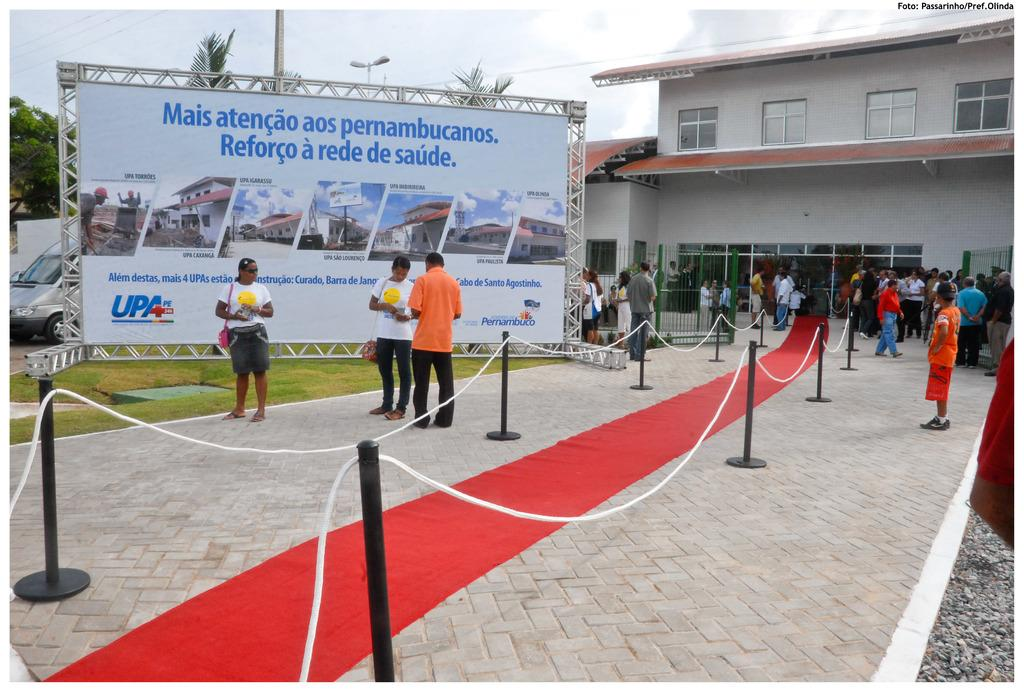What is the main structure visible in the image? There is a building in the image. Are there any people near the building? Yes, there are people standing in front of the building. What is placed in front of the building? A red carpet is placed in front of the building. How many cars are parked on the red carpet in the image? There are no cars visible in the image; only a building, people, and a red carpet are present. 